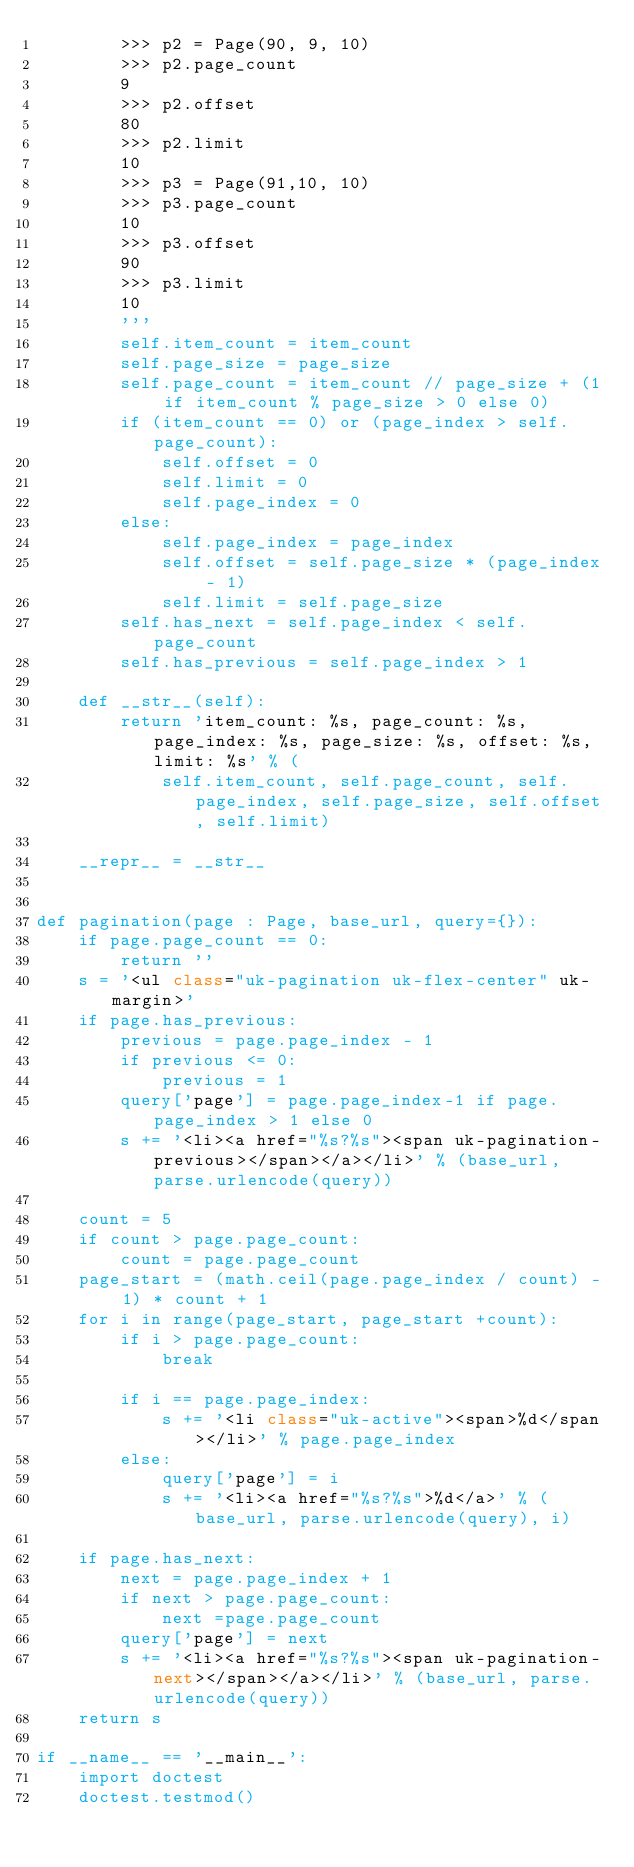<code> <loc_0><loc_0><loc_500><loc_500><_Python_>        >>> p2 = Page(90, 9, 10)
        >>> p2.page_count
        9
        >>> p2.offset
        80
        >>> p2.limit
        10
        >>> p3 = Page(91,10, 10)
        >>> p3.page_count
        10
        >>> p3.offset
        90
        >>> p3.limit
        10
        '''
        self.item_count = item_count
        self.page_size = page_size
        self.page_count = item_count // page_size + (1 if item_count % page_size > 0 else 0)
        if (item_count == 0) or (page_index > self.page_count):
            self.offset = 0
            self.limit = 0
            self.page_index = 0
        else:
            self.page_index = page_index
            self.offset = self.page_size * (page_index - 1)
            self.limit = self.page_size
        self.has_next = self.page_index < self.page_count
        self.has_previous = self.page_index > 1

    def __str__(self):
        return 'item_count: %s, page_count: %s, page_index: %s, page_size: %s, offset: %s, limit: %s' % (
            self.item_count, self.page_count, self.page_index, self.page_size, self.offset, self.limit)
    
    __repr__ = __str__


def pagination(page : Page, base_url, query={}):
    if page.page_count == 0:
        return ''
    s = '<ul class="uk-pagination uk-flex-center" uk-margin>'
    if page.has_previous:
        previous = page.page_index - 1
        if previous <= 0:
            previous = 1
        query['page'] = page.page_index-1 if page.page_index > 1 else 0
        s += '<li><a href="%s?%s"><span uk-pagination-previous></span></a></li>' % (base_url, parse.urlencode(query))

    count = 5
    if count > page.page_count:
        count = page.page_count
    page_start = (math.ceil(page.page_index / count) - 1) * count + 1
    for i in range(page_start, page_start +count):
        if i > page.page_count:
            break

        if i == page.page_index:
            s += '<li class="uk-active"><span>%d</span></li>' % page.page_index
        else:
            query['page'] = i
            s += '<li><a href="%s?%s">%d</a>' % (base_url, parse.urlencode(query), i)

    if page.has_next:
        next = page.page_index + 1
        if next > page.page_count:
            next =page.page_count
        query['page'] = next
        s += '<li><a href="%s?%s"><span uk-pagination-next></span></a></li>' % (base_url, parse.urlencode(query))
    return s

if __name__ == '__main__':
    import doctest
    doctest.testmod()</code> 